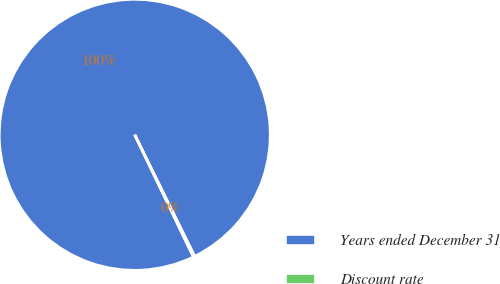Convert chart. <chart><loc_0><loc_0><loc_500><loc_500><pie_chart><fcel>Years ended December 31<fcel>Discount rate<nl><fcel>99.83%<fcel>0.17%<nl></chart> 